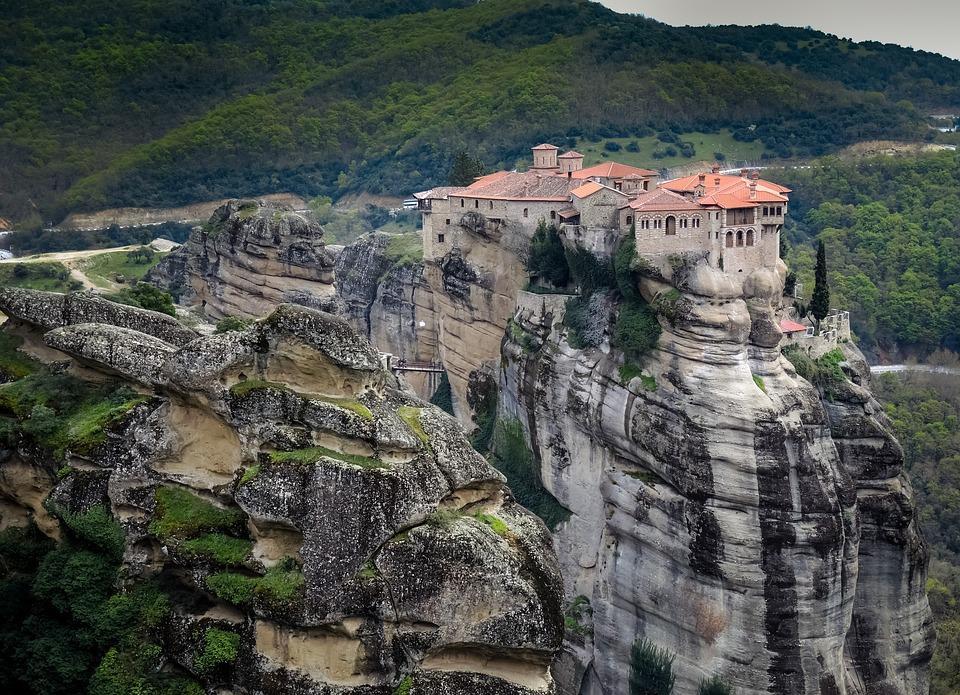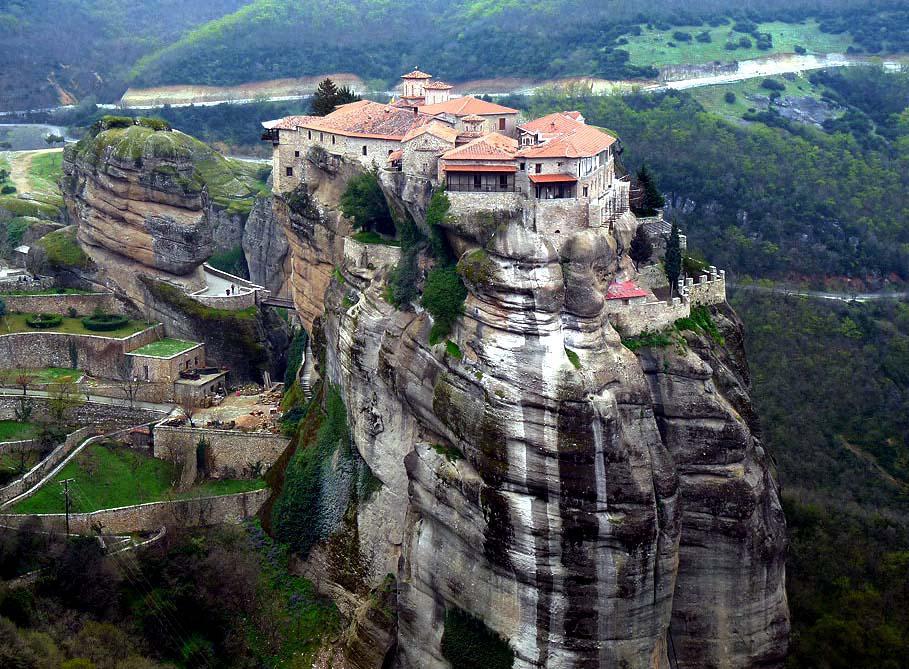The first image is the image on the left, the second image is the image on the right. Given the left and right images, does the statement "These images feature a home on a cliff side from the same angle, and from a similar distance." hold true? Answer yes or no. Yes. The first image is the image on the left, the second image is the image on the right. For the images displayed, is the sentence "Both images show a sky above the buildings on the cliffs." factually correct? Answer yes or no. No. 